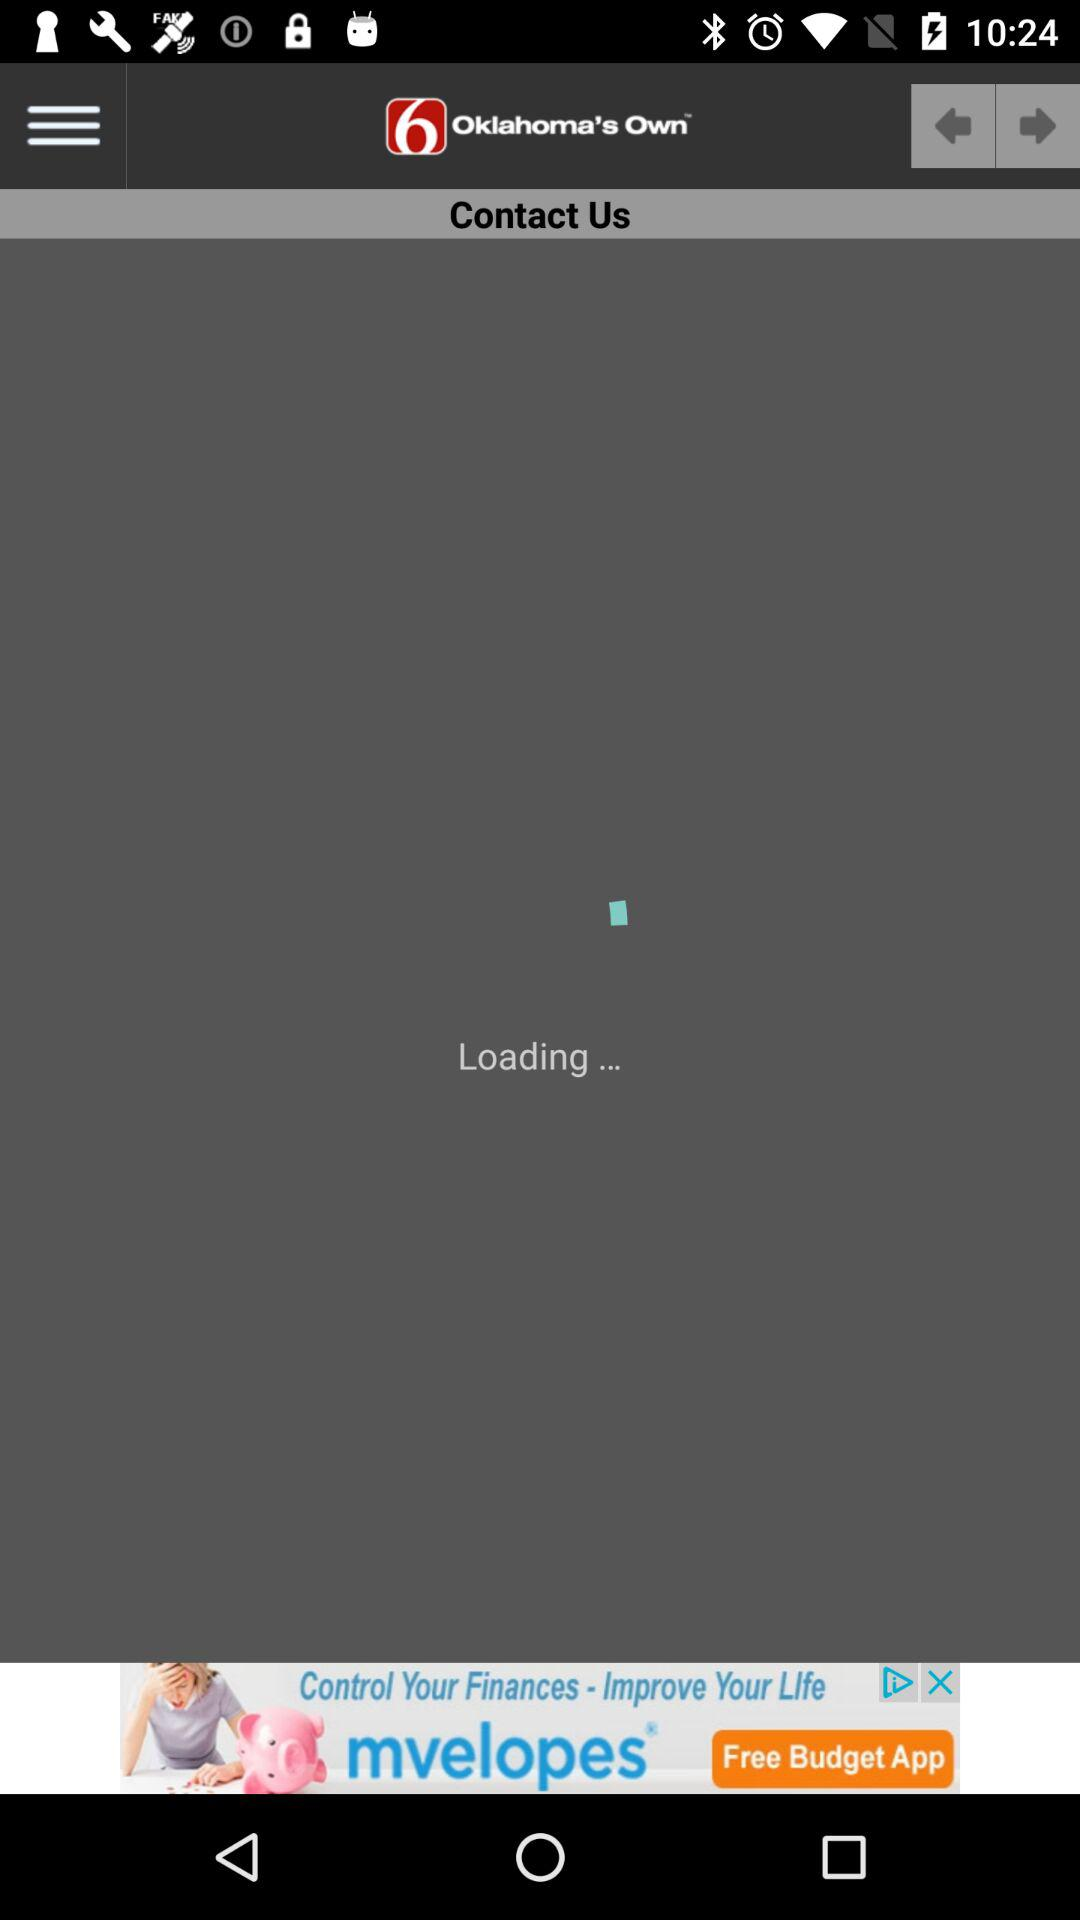When was the "Public Information File" published? The "Public Information File" was published on August 2, 2012 at 7:51 a.m. 